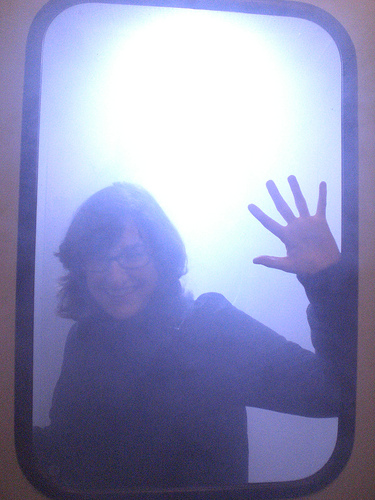<image>
Is the window behind the person? No. The window is not behind the person. From this viewpoint, the window appears to be positioned elsewhere in the scene. 